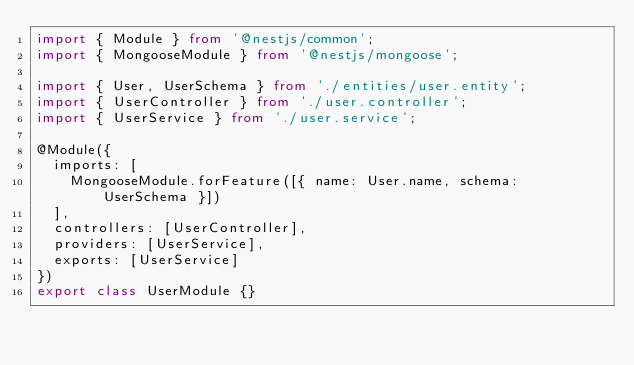Convert code to text. <code><loc_0><loc_0><loc_500><loc_500><_TypeScript_>import { Module } from '@nestjs/common';
import { MongooseModule } from '@nestjs/mongoose';

import { User, UserSchema } from './entities/user.entity';
import { UserController } from './user.controller';
import { UserService } from './user.service';

@Module({
  imports: [
    MongooseModule.forFeature([{ name: User.name, schema: UserSchema }])
  ],
  controllers: [UserController],
  providers: [UserService],
  exports: [UserService]
})
export class UserModule {}
</code> 